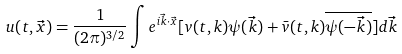Convert formula to latex. <formula><loc_0><loc_0><loc_500><loc_500>u ( t , \vec { x } ) = \frac { 1 } { ( 2 \pi ) ^ { 3 / 2 } } \int e ^ { i \vec { k } \cdot \vec { x } } [ v ( t , k ) \psi ( \vec { k } ) + \bar { v } ( t , k ) \overline { \psi ( - \vec { k } ) } ] d \vec { k }</formula> 